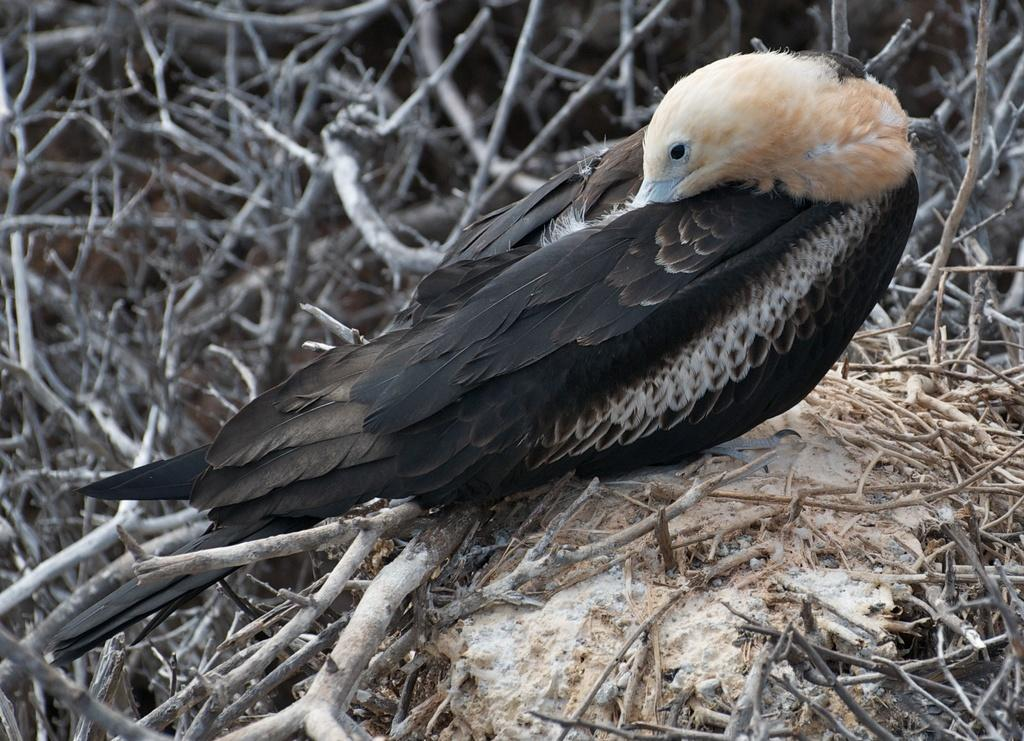What type of bird is in the picture? There is a vulture in the picture. What color is the vulture? The vulture is black in color. What can be seen beside the vulture? There are sticks beside the vulture. What hobbies does the vulture have in the picture? There is no information about the vulture's hobbies in the image. How does the vulture spark a conversation with the viewer? The vulture does not spark a conversation with the viewer in the image, as it is a static image and not an interactive medium. 